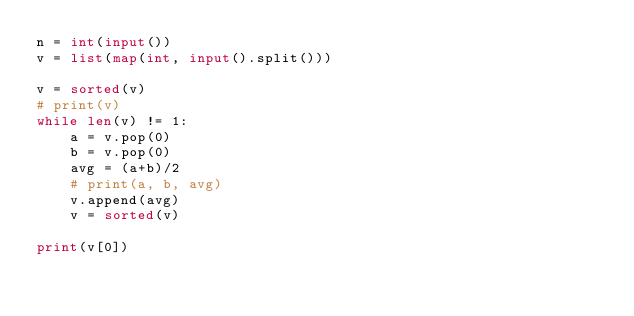Convert code to text. <code><loc_0><loc_0><loc_500><loc_500><_Python_>n = int(input())
v = list(map(int, input().split()))

v = sorted(v)
# print(v)
while len(v) != 1:
    a = v.pop(0)
    b = v.pop(0)
    avg = (a+b)/2
    # print(a, b, avg)
    v.append(avg)
    v = sorted(v)

print(v[0])
</code> 